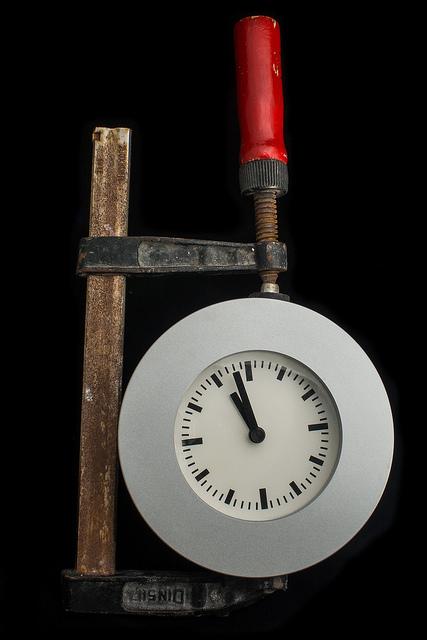What color is the background?
Quick response, please. Black. What color are the clock hands?
Answer briefly. Black. How long until 1pm?
Give a very brief answer. 2 minutes. 